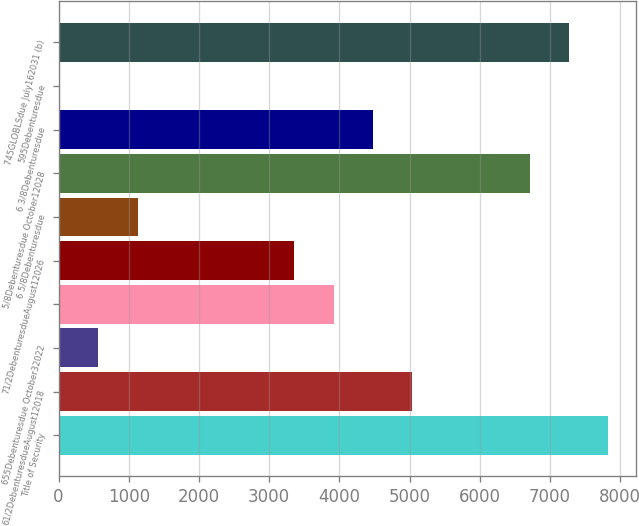Convert chart to OTSL. <chart><loc_0><loc_0><loc_500><loc_500><bar_chart><fcel>Title of Security<fcel>61/2DebenturesdueAugust12018<fcel>655Debenturesdue October32022<fcel>Unnamed: 3<fcel>71/2DebenturesdueAugust12026<fcel>6 5/8Debenturesdue<fcel>5/8Debenturesdue October12028<fcel>6 3/8Debenturesdue<fcel>595Debenturesdue<fcel>745GLOBLSdue July162031 (b)<nl><fcel>7828.4<fcel>5035.4<fcel>566.6<fcel>3918.2<fcel>3359.6<fcel>1125.2<fcel>6711.2<fcel>4476.8<fcel>8<fcel>7269.8<nl></chart> 